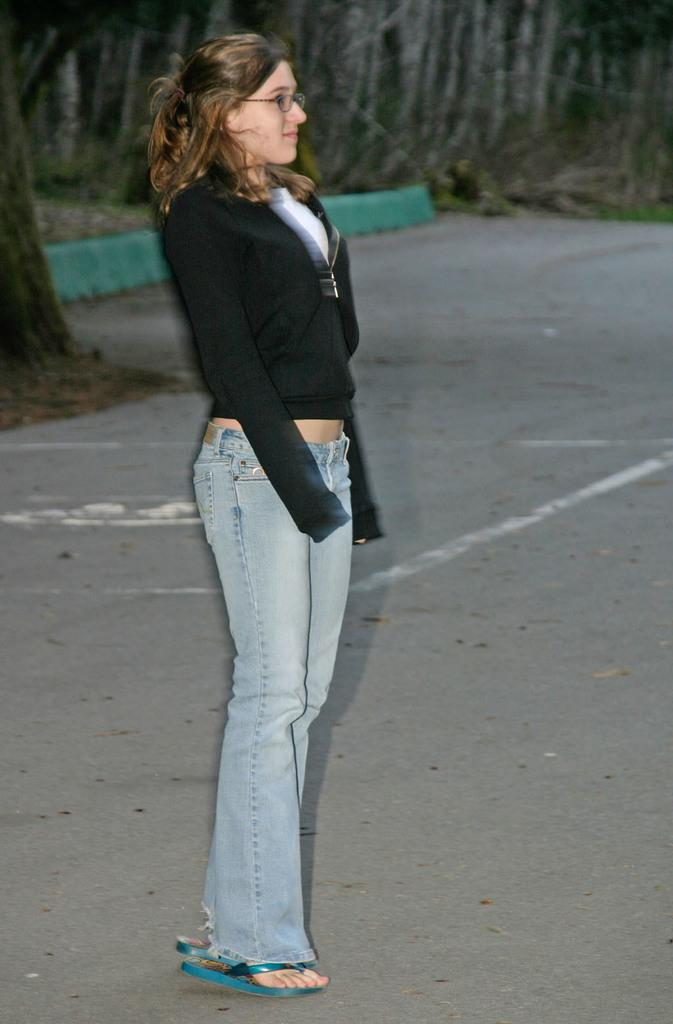Who is present in the image? There is a woman in the image. What is the woman doing in the image? The woman is standing on the road. What can be seen in the background of the image? There are trees visible in the background of the image. What type of clover is the woman holding in the image? There is no clover present in the image; the woman is standing on the road with no visible objects in her hands. 